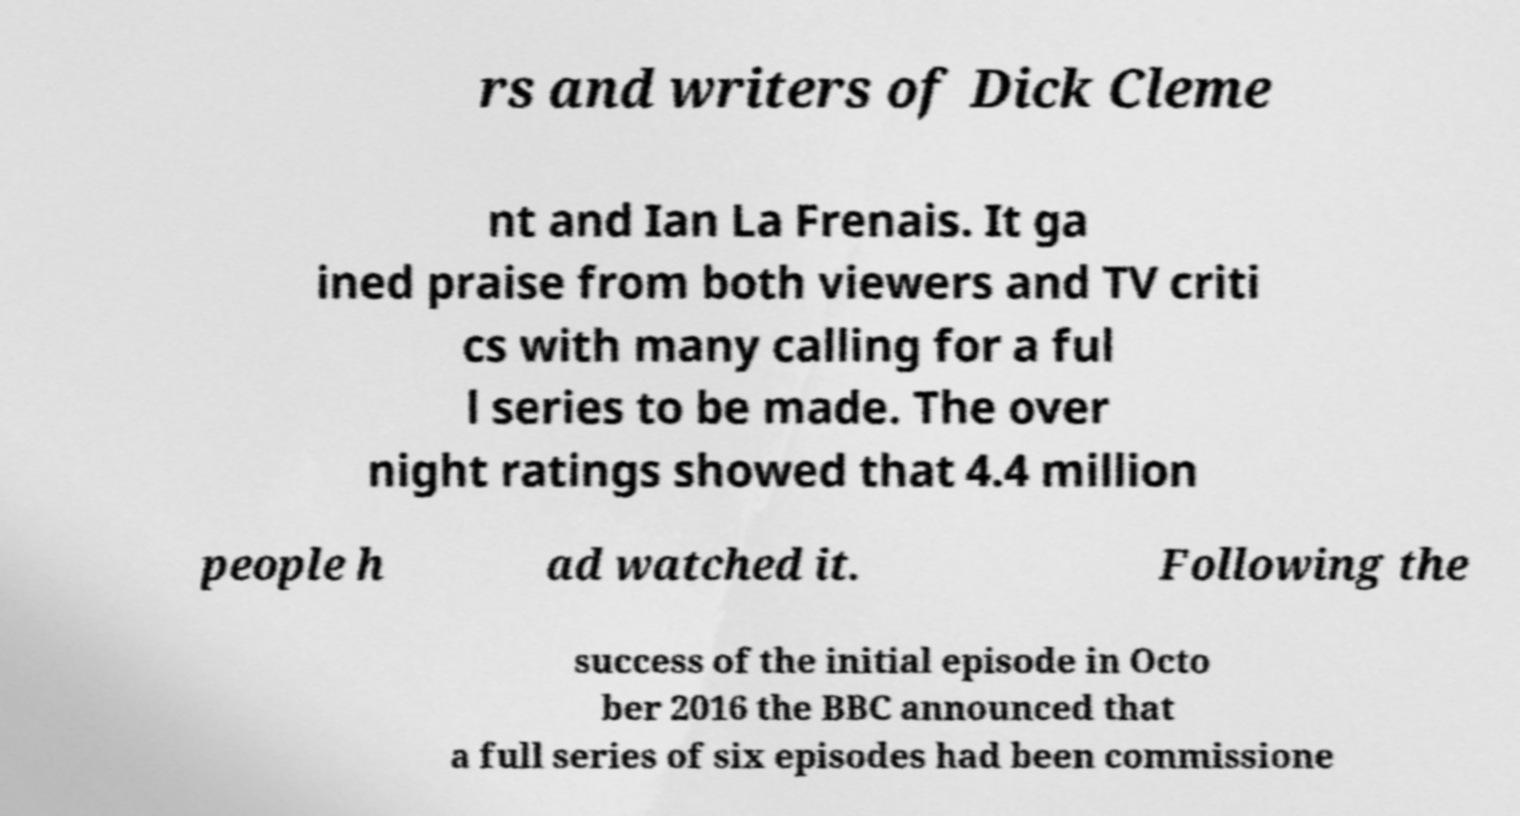Can you accurately transcribe the text from the provided image for me? rs and writers of Dick Cleme nt and Ian La Frenais. It ga ined praise from both viewers and TV criti cs with many calling for a ful l series to be made. The over night ratings showed that 4.4 million people h ad watched it. Following the success of the initial episode in Octo ber 2016 the BBC announced that a full series of six episodes had been commissione 